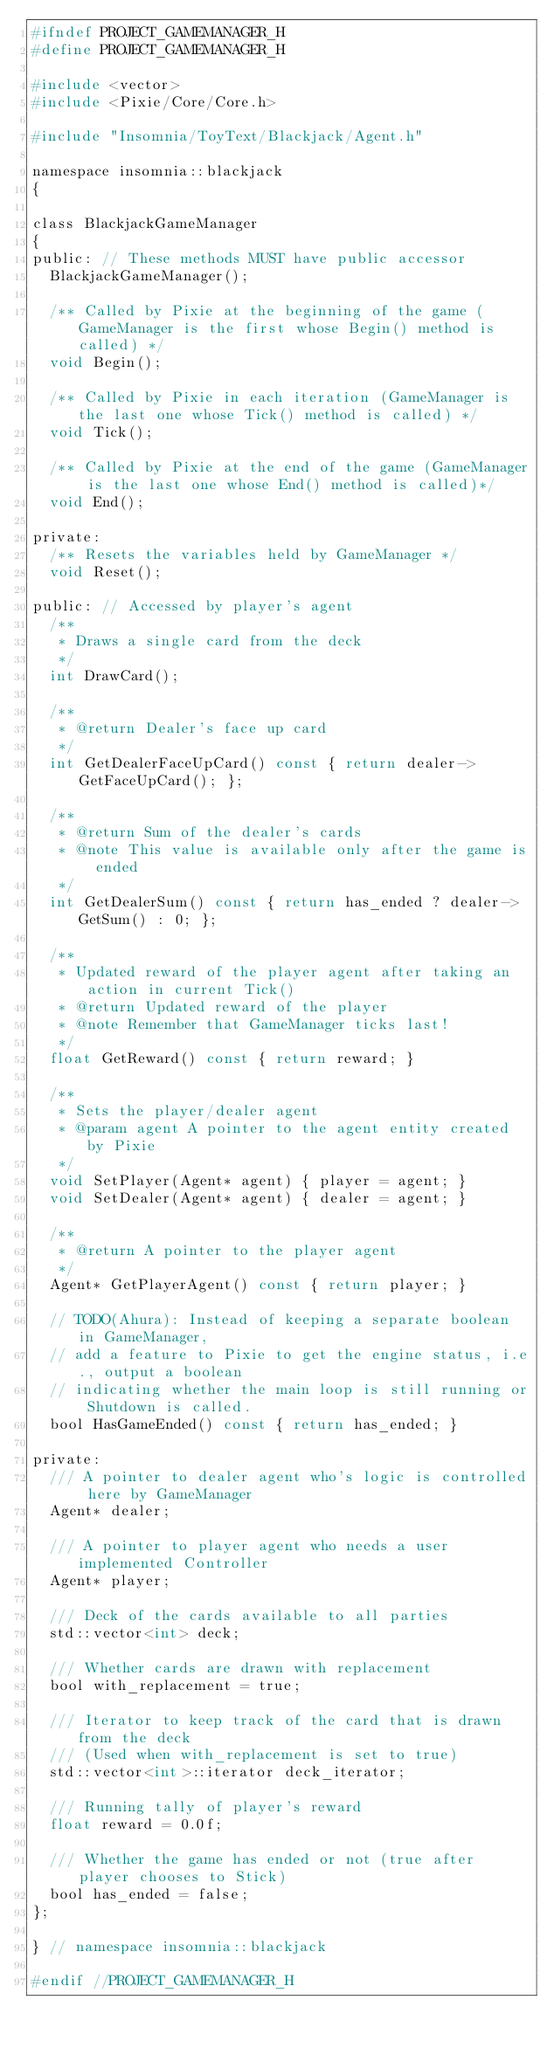<code> <loc_0><loc_0><loc_500><loc_500><_C_>#ifndef PROJECT_GAMEMANAGER_H
#define PROJECT_GAMEMANAGER_H

#include <vector>
#include <Pixie/Core/Core.h>

#include "Insomnia/ToyText/Blackjack/Agent.h"

namespace insomnia::blackjack
{

class BlackjackGameManager
{
public: // These methods MUST have public accessor
	BlackjackGameManager();

	/** Called by Pixie at the beginning of the game (GameManager is the first whose Begin() method is called) */
	void Begin();

	/** Called by Pixie in each iteration (GameManager is the last one whose Tick() method is called) */
	void Tick();

	/** Called by Pixie at the end of the game (GameManager is the last one whose End() method is called)*/
	void End();

private:
	/** Resets the variables held by GameManager */
	void Reset();

public: // Accessed by player's agent
	/**
	 * Draws a single card from the deck
	 */
	int DrawCard();

	/**
	 * @return Dealer's face up card
	 */
	int GetDealerFaceUpCard() const { return dealer->GetFaceUpCard(); };

	/**
	 * @return Sum of the dealer's cards
	 * @note This value is available only after the game is ended
	 */
	int GetDealerSum() const { return has_ended ? dealer->GetSum() : 0; };

	/**
	 * Updated reward of the player agent after taking an action in current Tick()
	 * @return Updated reward of the player
	 * @note Remember that GameManager ticks last!
	 */
	float GetReward() const { return reward; }

	/**
	 * Sets the player/dealer agent
	 * @param agent A pointer to the agent entity created by Pixie
	 */
	void SetPlayer(Agent* agent) { player = agent; }
	void SetDealer(Agent* agent) { dealer = agent; }

	/**
	 * @return A pointer to the player agent
	 */
	Agent* GetPlayerAgent() const { return player; }

	// TODO(Ahura): Instead of keeping a separate boolean in GameManager,
	// add a feature to Pixie to get the engine status, i.e., output a boolean
	// indicating whether the main loop is still running or Shutdown is called.
	bool HasGameEnded() const { return has_ended; }

private:
	/// A pointer to dealer agent who's logic is controlled here by GameManager
	Agent* dealer;

	/// A pointer to player agent who needs a user implemented Controller
	Agent* player;

	/// Deck of the cards available to all parties
	std::vector<int> deck;

	/// Whether cards are drawn with replacement
	bool with_replacement = true;

	/// Iterator to keep track of the card that is drawn from the deck
	/// (Used when with_replacement is set to true)
	std::vector<int>::iterator deck_iterator;

	/// Running tally of player's reward
	float reward = 0.0f;

	/// Whether the game has ended or not (true after player chooses to Stick)
	bool has_ended = false;
};

} // namespace insomnia::blackjack

#endif //PROJECT_GAMEMANAGER_H
</code> 